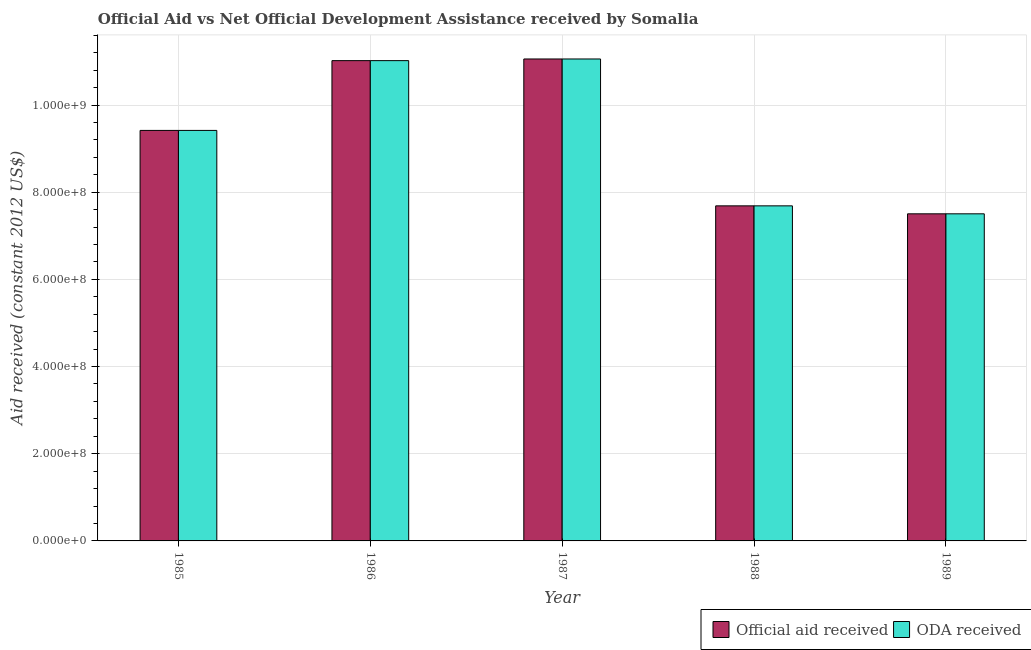How many different coloured bars are there?
Provide a short and direct response. 2. How many groups of bars are there?
Provide a succinct answer. 5. Are the number of bars per tick equal to the number of legend labels?
Your answer should be very brief. Yes. How many bars are there on the 4th tick from the left?
Make the answer very short. 2. What is the label of the 2nd group of bars from the left?
Provide a short and direct response. 1986. What is the oda received in 1986?
Make the answer very short. 1.10e+09. Across all years, what is the maximum oda received?
Give a very brief answer. 1.11e+09. Across all years, what is the minimum official aid received?
Offer a terse response. 7.50e+08. In which year was the official aid received minimum?
Offer a very short reply. 1989. What is the total oda received in the graph?
Give a very brief answer. 4.67e+09. What is the difference between the official aid received in 1987 and that in 1988?
Provide a short and direct response. 3.37e+08. What is the difference between the official aid received in 1985 and the oda received in 1986?
Provide a succinct answer. -1.60e+08. What is the average official aid received per year?
Make the answer very short. 9.34e+08. In the year 1989, what is the difference between the official aid received and oda received?
Provide a short and direct response. 0. What is the ratio of the oda received in 1985 to that in 1989?
Your answer should be compact. 1.25. Is the difference between the official aid received in 1987 and 1988 greater than the difference between the oda received in 1987 and 1988?
Ensure brevity in your answer.  No. What is the difference between the highest and the second highest official aid received?
Offer a very short reply. 3.81e+06. What is the difference between the highest and the lowest official aid received?
Offer a very short reply. 3.55e+08. Is the sum of the oda received in 1987 and 1988 greater than the maximum official aid received across all years?
Give a very brief answer. Yes. What does the 1st bar from the left in 1987 represents?
Offer a very short reply. Official aid received. What does the 2nd bar from the right in 1985 represents?
Your answer should be compact. Official aid received. How many bars are there?
Provide a short and direct response. 10. How many years are there in the graph?
Make the answer very short. 5. What is the difference between two consecutive major ticks on the Y-axis?
Offer a terse response. 2.00e+08. Are the values on the major ticks of Y-axis written in scientific E-notation?
Keep it short and to the point. Yes. Does the graph contain any zero values?
Make the answer very short. No. How are the legend labels stacked?
Your response must be concise. Horizontal. What is the title of the graph?
Ensure brevity in your answer.  Official Aid vs Net Official Development Assistance received by Somalia . Does "Investment" appear as one of the legend labels in the graph?
Provide a succinct answer. No. What is the label or title of the X-axis?
Ensure brevity in your answer.  Year. What is the label or title of the Y-axis?
Give a very brief answer. Aid received (constant 2012 US$). What is the Aid received (constant 2012 US$) of Official aid received in 1985?
Offer a very short reply. 9.42e+08. What is the Aid received (constant 2012 US$) of ODA received in 1985?
Your answer should be very brief. 9.42e+08. What is the Aid received (constant 2012 US$) of Official aid received in 1986?
Your answer should be very brief. 1.10e+09. What is the Aid received (constant 2012 US$) in ODA received in 1986?
Your answer should be compact. 1.10e+09. What is the Aid received (constant 2012 US$) in Official aid received in 1987?
Provide a short and direct response. 1.11e+09. What is the Aid received (constant 2012 US$) of ODA received in 1987?
Give a very brief answer. 1.11e+09. What is the Aid received (constant 2012 US$) in Official aid received in 1988?
Keep it short and to the point. 7.69e+08. What is the Aid received (constant 2012 US$) in ODA received in 1988?
Provide a short and direct response. 7.69e+08. What is the Aid received (constant 2012 US$) of Official aid received in 1989?
Offer a very short reply. 7.50e+08. What is the Aid received (constant 2012 US$) of ODA received in 1989?
Offer a very short reply. 7.50e+08. Across all years, what is the maximum Aid received (constant 2012 US$) in Official aid received?
Give a very brief answer. 1.11e+09. Across all years, what is the maximum Aid received (constant 2012 US$) in ODA received?
Keep it short and to the point. 1.11e+09. Across all years, what is the minimum Aid received (constant 2012 US$) in Official aid received?
Provide a short and direct response. 7.50e+08. Across all years, what is the minimum Aid received (constant 2012 US$) in ODA received?
Offer a very short reply. 7.50e+08. What is the total Aid received (constant 2012 US$) of Official aid received in the graph?
Provide a short and direct response. 4.67e+09. What is the total Aid received (constant 2012 US$) of ODA received in the graph?
Provide a succinct answer. 4.67e+09. What is the difference between the Aid received (constant 2012 US$) of Official aid received in 1985 and that in 1986?
Offer a terse response. -1.60e+08. What is the difference between the Aid received (constant 2012 US$) of ODA received in 1985 and that in 1986?
Provide a short and direct response. -1.60e+08. What is the difference between the Aid received (constant 2012 US$) in Official aid received in 1985 and that in 1987?
Provide a short and direct response. -1.64e+08. What is the difference between the Aid received (constant 2012 US$) of ODA received in 1985 and that in 1987?
Provide a succinct answer. -1.64e+08. What is the difference between the Aid received (constant 2012 US$) in Official aid received in 1985 and that in 1988?
Make the answer very short. 1.73e+08. What is the difference between the Aid received (constant 2012 US$) of ODA received in 1985 and that in 1988?
Offer a very short reply. 1.73e+08. What is the difference between the Aid received (constant 2012 US$) in Official aid received in 1985 and that in 1989?
Your answer should be very brief. 1.91e+08. What is the difference between the Aid received (constant 2012 US$) of ODA received in 1985 and that in 1989?
Give a very brief answer. 1.91e+08. What is the difference between the Aid received (constant 2012 US$) in Official aid received in 1986 and that in 1987?
Your answer should be very brief. -3.81e+06. What is the difference between the Aid received (constant 2012 US$) of ODA received in 1986 and that in 1987?
Offer a terse response. -3.81e+06. What is the difference between the Aid received (constant 2012 US$) of Official aid received in 1986 and that in 1988?
Offer a terse response. 3.33e+08. What is the difference between the Aid received (constant 2012 US$) of ODA received in 1986 and that in 1988?
Make the answer very short. 3.33e+08. What is the difference between the Aid received (constant 2012 US$) in Official aid received in 1986 and that in 1989?
Your response must be concise. 3.51e+08. What is the difference between the Aid received (constant 2012 US$) of ODA received in 1986 and that in 1989?
Your answer should be compact. 3.51e+08. What is the difference between the Aid received (constant 2012 US$) of Official aid received in 1987 and that in 1988?
Keep it short and to the point. 3.37e+08. What is the difference between the Aid received (constant 2012 US$) of ODA received in 1987 and that in 1988?
Ensure brevity in your answer.  3.37e+08. What is the difference between the Aid received (constant 2012 US$) of Official aid received in 1987 and that in 1989?
Offer a very short reply. 3.55e+08. What is the difference between the Aid received (constant 2012 US$) of ODA received in 1987 and that in 1989?
Ensure brevity in your answer.  3.55e+08. What is the difference between the Aid received (constant 2012 US$) in Official aid received in 1988 and that in 1989?
Keep it short and to the point. 1.83e+07. What is the difference between the Aid received (constant 2012 US$) of ODA received in 1988 and that in 1989?
Keep it short and to the point. 1.83e+07. What is the difference between the Aid received (constant 2012 US$) in Official aid received in 1985 and the Aid received (constant 2012 US$) in ODA received in 1986?
Your response must be concise. -1.60e+08. What is the difference between the Aid received (constant 2012 US$) in Official aid received in 1985 and the Aid received (constant 2012 US$) in ODA received in 1987?
Your answer should be compact. -1.64e+08. What is the difference between the Aid received (constant 2012 US$) of Official aid received in 1985 and the Aid received (constant 2012 US$) of ODA received in 1988?
Your answer should be compact. 1.73e+08. What is the difference between the Aid received (constant 2012 US$) in Official aid received in 1985 and the Aid received (constant 2012 US$) in ODA received in 1989?
Your answer should be very brief. 1.91e+08. What is the difference between the Aid received (constant 2012 US$) in Official aid received in 1986 and the Aid received (constant 2012 US$) in ODA received in 1987?
Make the answer very short. -3.81e+06. What is the difference between the Aid received (constant 2012 US$) in Official aid received in 1986 and the Aid received (constant 2012 US$) in ODA received in 1988?
Make the answer very short. 3.33e+08. What is the difference between the Aid received (constant 2012 US$) of Official aid received in 1986 and the Aid received (constant 2012 US$) of ODA received in 1989?
Provide a succinct answer. 3.51e+08. What is the difference between the Aid received (constant 2012 US$) of Official aid received in 1987 and the Aid received (constant 2012 US$) of ODA received in 1988?
Offer a very short reply. 3.37e+08. What is the difference between the Aid received (constant 2012 US$) of Official aid received in 1987 and the Aid received (constant 2012 US$) of ODA received in 1989?
Offer a very short reply. 3.55e+08. What is the difference between the Aid received (constant 2012 US$) in Official aid received in 1988 and the Aid received (constant 2012 US$) in ODA received in 1989?
Keep it short and to the point. 1.83e+07. What is the average Aid received (constant 2012 US$) in Official aid received per year?
Make the answer very short. 9.34e+08. What is the average Aid received (constant 2012 US$) of ODA received per year?
Give a very brief answer. 9.34e+08. In the year 1985, what is the difference between the Aid received (constant 2012 US$) of Official aid received and Aid received (constant 2012 US$) of ODA received?
Give a very brief answer. 0. In the year 1987, what is the difference between the Aid received (constant 2012 US$) in Official aid received and Aid received (constant 2012 US$) in ODA received?
Offer a terse response. 0. In the year 1988, what is the difference between the Aid received (constant 2012 US$) in Official aid received and Aid received (constant 2012 US$) in ODA received?
Keep it short and to the point. 0. In the year 1989, what is the difference between the Aid received (constant 2012 US$) of Official aid received and Aid received (constant 2012 US$) of ODA received?
Keep it short and to the point. 0. What is the ratio of the Aid received (constant 2012 US$) of Official aid received in 1985 to that in 1986?
Keep it short and to the point. 0.85. What is the ratio of the Aid received (constant 2012 US$) in ODA received in 1985 to that in 1986?
Provide a succinct answer. 0.85. What is the ratio of the Aid received (constant 2012 US$) in Official aid received in 1985 to that in 1987?
Ensure brevity in your answer.  0.85. What is the ratio of the Aid received (constant 2012 US$) of ODA received in 1985 to that in 1987?
Offer a very short reply. 0.85. What is the ratio of the Aid received (constant 2012 US$) of Official aid received in 1985 to that in 1988?
Your answer should be compact. 1.23. What is the ratio of the Aid received (constant 2012 US$) in ODA received in 1985 to that in 1988?
Keep it short and to the point. 1.23. What is the ratio of the Aid received (constant 2012 US$) of Official aid received in 1985 to that in 1989?
Make the answer very short. 1.25. What is the ratio of the Aid received (constant 2012 US$) of ODA received in 1985 to that in 1989?
Give a very brief answer. 1.25. What is the ratio of the Aid received (constant 2012 US$) in Official aid received in 1986 to that in 1987?
Give a very brief answer. 1. What is the ratio of the Aid received (constant 2012 US$) in ODA received in 1986 to that in 1987?
Provide a short and direct response. 1. What is the ratio of the Aid received (constant 2012 US$) of Official aid received in 1986 to that in 1988?
Your answer should be compact. 1.43. What is the ratio of the Aid received (constant 2012 US$) in ODA received in 1986 to that in 1988?
Ensure brevity in your answer.  1.43. What is the ratio of the Aid received (constant 2012 US$) of Official aid received in 1986 to that in 1989?
Make the answer very short. 1.47. What is the ratio of the Aid received (constant 2012 US$) of ODA received in 1986 to that in 1989?
Your answer should be very brief. 1.47. What is the ratio of the Aid received (constant 2012 US$) of Official aid received in 1987 to that in 1988?
Give a very brief answer. 1.44. What is the ratio of the Aid received (constant 2012 US$) in ODA received in 1987 to that in 1988?
Provide a succinct answer. 1.44. What is the ratio of the Aid received (constant 2012 US$) in Official aid received in 1987 to that in 1989?
Your answer should be compact. 1.47. What is the ratio of the Aid received (constant 2012 US$) in ODA received in 1987 to that in 1989?
Your response must be concise. 1.47. What is the ratio of the Aid received (constant 2012 US$) in Official aid received in 1988 to that in 1989?
Ensure brevity in your answer.  1.02. What is the ratio of the Aid received (constant 2012 US$) of ODA received in 1988 to that in 1989?
Your answer should be compact. 1.02. What is the difference between the highest and the second highest Aid received (constant 2012 US$) in Official aid received?
Make the answer very short. 3.81e+06. What is the difference between the highest and the second highest Aid received (constant 2012 US$) of ODA received?
Provide a succinct answer. 3.81e+06. What is the difference between the highest and the lowest Aid received (constant 2012 US$) in Official aid received?
Keep it short and to the point. 3.55e+08. What is the difference between the highest and the lowest Aid received (constant 2012 US$) in ODA received?
Offer a very short reply. 3.55e+08. 